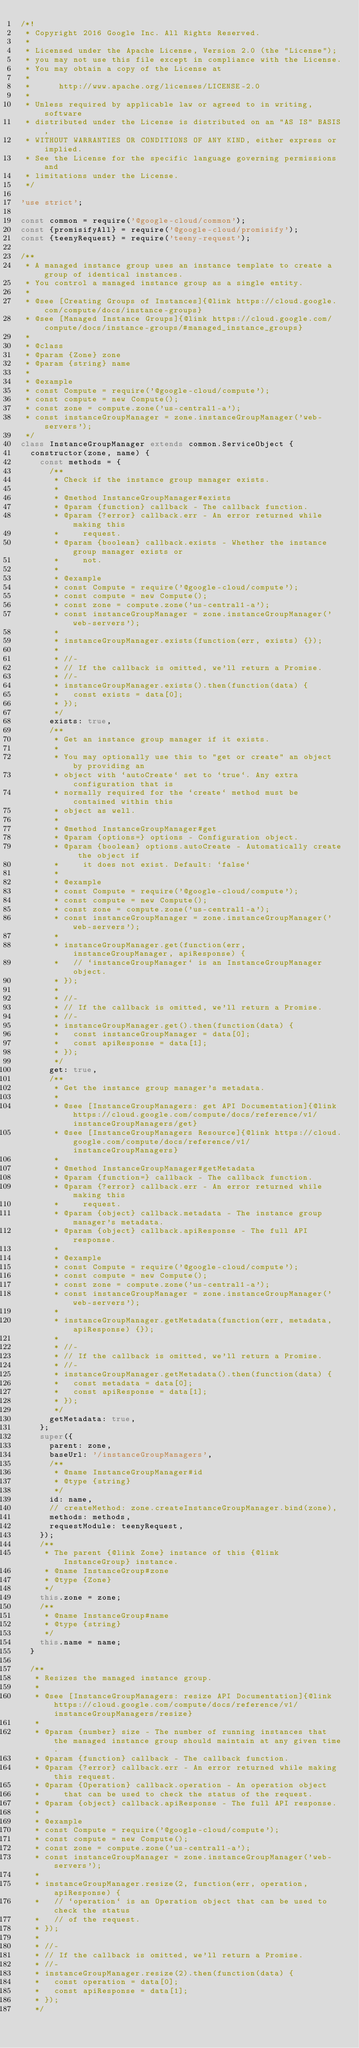Convert code to text. <code><loc_0><loc_0><loc_500><loc_500><_JavaScript_>/*!
 * Copyright 2016 Google Inc. All Rights Reserved.
 *
 * Licensed under the Apache License, Version 2.0 (the "License");
 * you may not use this file except in compliance with the License.
 * You may obtain a copy of the License at
 *
 *      http://www.apache.org/licenses/LICENSE-2.0
 *
 * Unless required by applicable law or agreed to in writing, software
 * distributed under the License is distributed on an "AS IS" BASIS,
 * WITHOUT WARRANTIES OR CONDITIONS OF ANY KIND, either express or implied.
 * See the License for the specific language governing permissions and
 * limitations under the License.
 */

'use strict';

const common = require('@google-cloud/common');
const {promisifyAll} = require('@google-cloud/promisify');
const {teenyRequest} = require('teeny-request');

/**
 * A managed instance group uses an instance template to create a group of identical instances.
 * You control a managed instance group as a single entity.
 *
 * @see [Creating Groups of Instances]{@link https://cloud.google.com/compute/docs/instance-groups}
 * @see [Managed Instance Groups]{@link https://cloud.google.com/compute/docs/instance-groups/#managed_instance_groups}
 *
 * @class
 * @param {Zone} zone
 * @param {string} name
 *
 * @example
 * const Compute = require('@google-cloud/compute');
 * const compute = new Compute();
 * const zone = compute.zone('us-central1-a');
 * const instanceGroupManager = zone.instanceGroupManager('web-servers');
 */
class InstanceGroupManager extends common.ServiceObject {
  constructor(zone, name) {
    const methods = {
      /**
       * Check if the instance group manager exists.
       *
       * @method InstanceGroupManager#exists
       * @param {function} callback - The callback function.
       * @param {?error} callback.err - An error returned while making this
       *     request.
       * @param {boolean} callback.exists - Whether the instance group manager exists or
       *     not.
       *
       * @example
       * const Compute = require('@google-cloud/compute');
       * const compute = new Compute();
       * const zone = compute.zone('us-central1-a');
       * const instanceGroupManager = zone.instanceGroupManager('web-servers');
       *
       * instanceGroupManager.exists(function(err, exists) {});
       *
       * //-
       * // If the callback is omitted, we'll return a Promise.
       * //-
       * instanceGroupManager.exists().then(function(data) {
       *   const exists = data[0];
       * });
       */
      exists: true,
      /**
       * Get an instance group manager if it exists.
       *
       * You may optionally use this to "get or create" an object by providing an
       * object with `autoCreate` set to `true`. Any extra configuration that is
       * normally required for the `create` method must be contained within this
       * object as well.
       *
       * @method InstanceGroupManager#get
       * @param {options=} options - Configuration object.
       * @param {boolean} options.autoCreate - Automatically create the object if
       *     it does not exist. Default: `false`
       *
       * @example
       * const Compute = require('@google-cloud/compute');
       * const compute = new Compute();
       * const zone = compute.zone('us-central1-a');
       * const instanceGroupManager = zone.instanceGroupManager('web-servers');
       *
       * instanceGroupManager.get(function(err, instanceGroupManager, apiResponse) {
       *   // `instanceGroupManager` is an InstanceGroupManager object.
       * });
       *
       * //-
       * // If the callback is omitted, we'll return a Promise.
       * //-
       * instanceGroupManager.get().then(function(data) {
       *   const instanceGroupManager = data[0];
       *   const apiResponse = data[1];
       * });
       */
      get: true,
      /**
       * Get the instance group manager's metadata.
       *
       * @see [InstanceGroupManagers: get API Documentation]{@link https://cloud.google.com/compute/docs/reference/v1/instanceGroupManagers/get}
       * @see [InstanceGroupManagers Resource]{@link https://cloud.google.com/compute/docs/reference/v1/instanceGroupManagers}
       *
       * @method InstanceGroupManager#getMetadata
       * @param {function=} callback - The callback function.
       * @param {?error} callback.err - An error returned while making this
       *     request.
       * @param {object} callback.metadata - The instance group manager's metadata.
       * @param {object} callback.apiResponse - The full API response.
       *
       * @example
       * const Compute = require('@google-cloud/compute');
       * const compute = new Compute();
       * const zone = compute.zone('us-central1-a');
       * const instanceGroupManager = zone.instanceGroupManager('web-servers');
       *
       * instanceGroupManager.getMetadata(function(err, metadata, apiResponse) {});
       *
       * //-
       * // If the callback is omitted, we'll return a Promise.
       * //-
       * instanceGroupManager.getMetadata().then(function(data) {
       *   const metadata = data[0];
       *   const apiResponse = data[1];
       * });
       */
      getMetadata: true,
    };
    super({
      parent: zone,
      baseUrl: '/instanceGroupManagers',
      /**
       * @name InstanceGroupManager#id
       * @type {string}
       */
      id: name,
      // createMethod: zone.createInstanceGroupManager.bind(zone),
      methods: methods,
      requestModule: teenyRequest,
    });
    /**
     * The parent {@link Zone} instance of this {@link InstanceGroup} instance.
     * @name InstanceGroup#zone
     * @type {Zone}
     */
    this.zone = zone;
    /**
     * @name InstanceGroup#name
     * @type {string}
     */
    this.name = name;
  }

  /**
   * Resizes the managed instance group.
   *
   * @see [InstanceGroupManagers: resize API Documentation]{@link https://cloud.google.com/compute/docs/reference/v1/instanceGroupManagers/resize}
   *
   * @param {number} size - The number of running instances that the managed instance group should maintain at any given time.
   * @param {function} callback - The callback function.
   * @param {?error} callback.err - An error returned while making this request.
   * @param {Operation} callback.operation - An operation object
   *     that can be used to check the status of the request.
   * @param {object} callback.apiResponse - The full API response.
   *
   * @example
   * const Compute = require('@google-cloud/compute');
   * const compute = new Compute();
   * const zone = compute.zone('us-central1-a');
   * const instanceGroupManager = zone.instanceGroupManager('web-servers');
   *
   * instanceGroupManager.resize(2, function(err, operation, apiResponse) {
   *   // `operation` is an Operation object that can be used to check the status
   *   // of the request.
   * });
   *
   * //-
   * // If the callback is omitted, we'll return a Promise.
   * //-
   * instanceGroupManager.resize(2).then(function(data) {
   *   const operation = data[0];
   *   const apiResponse = data[1];
   * });
   */</code> 